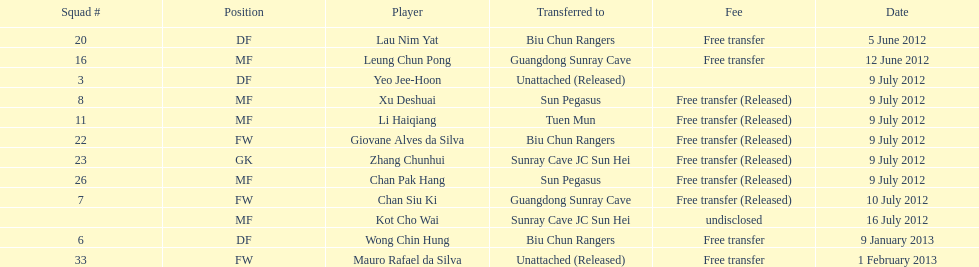How many uninterrupted players were set free on july 9? 6. 